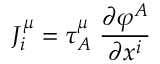<formula> <loc_0><loc_0><loc_500><loc_500>J _ { i } ^ { \mu } = \tau _ { A } ^ { \mu } \, \frac { \partial \varphi ^ { A } } { \partial x ^ { i } }</formula> 